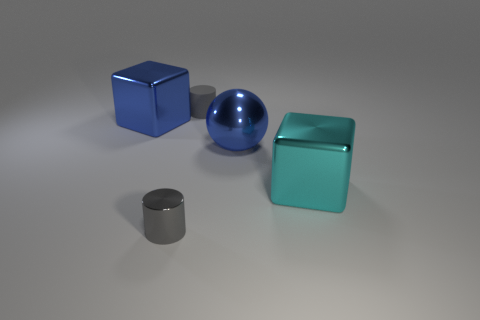Add 1 blue balls. How many objects exist? 6 Subtract 1 cylinders. How many cylinders are left? 1 Subtract 0 purple blocks. How many objects are left? 5 Subtract all blocks. How many objects are left? 3 Subtract all brown blocks. Subtract all gray spheres. How many blocks are left? 2 Subtract all gray cylinders. How many blue blocks are left? 1 Subtract all small yellow balls. Subtract all gray cylinders. How many objects are left? 3 Add 5 large blue metallic cubes. How many large blue metallic cubes are left? 6 Add 1 matte cylinders. How many matte cylinders exist? 2 